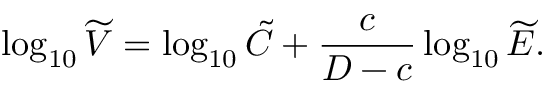Convert formula to latex. <formula><loc_0><loc_0><loc_500><loc_500>\log _ { 1 0 } \widetilde { V } = \log _ { 1 0 } \tilde { C } + \frac { c } { D - c } \log _ { 1 0 } \widetilde { E } .</formula> 